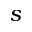Convert formula to latex. <formula><loc_0><loc_0><loc_500><loc_500>s</formula> 